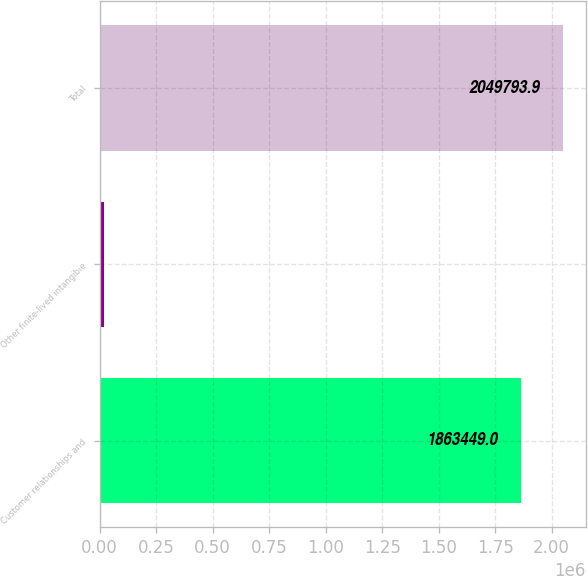<chart> <loc_0><loc_0><loc_500><loc_500><bar_chart><fcel>Customer relationships and<fcel>Other finite-lived intangible<fcel>Total<nl><fcel>1.86345e+06<fcel>20929<fcel>2.04979e+06<nl></chart> 